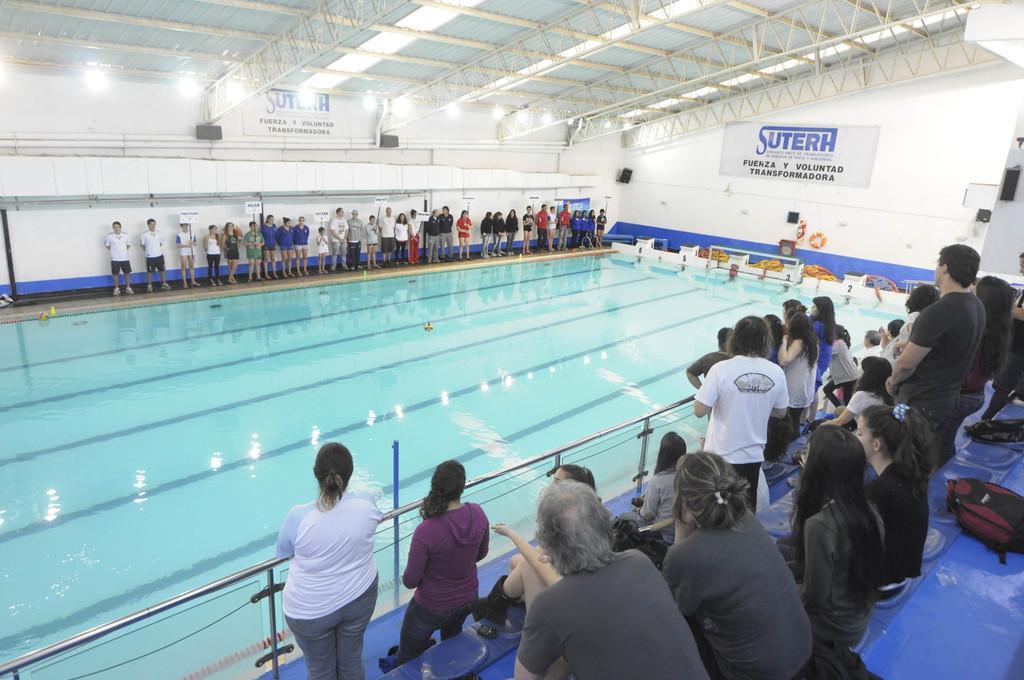Describe this image in one or two sentences. In this image I can see number of persons are standing on the blue colored surface and I can see few of them are sitting. I can see the water in the pool, few persons standing, the white colored walls, two boards, the ceiling and few lights. 